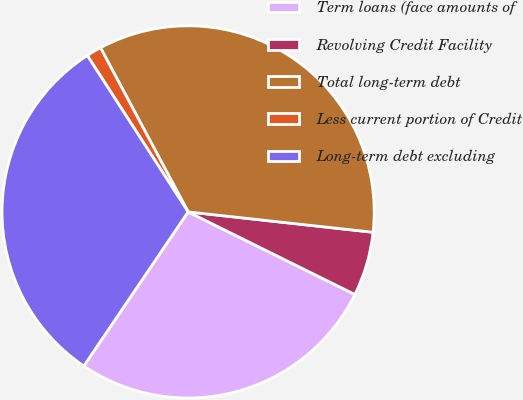Convert chart. <chart><loc_0><loc_0><loc_500><loc_500><pie_chart><fcel>Term loans (face amounts of<fcel>Revolving Credit Facility<fcel>Total long-term debt<fcel>Less current portion of Credit<fcel>Long-term debt excluding<nl><fcel>27.15%<fcel>5.57%<fcel>34.55%<fcel>1.31%<fcel>31.41%<nl></chart> 